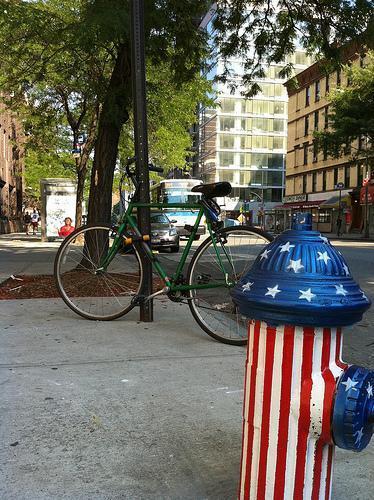How many fire hydrants are there?
Give a very brief answer. 1. How many bicycles are pictured?
Give a very brief answer. 1. 